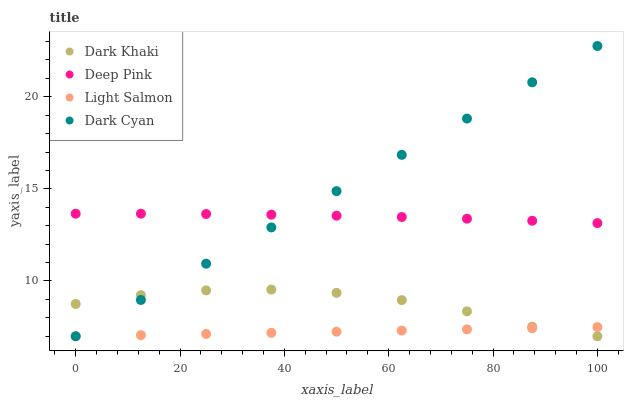Does Light Salmon have the minimum area under the curve?
Answer yes or no. Yes. Does Dark Cyan have the maximum area under the curve?
Answer yes or no. Yes. Does Dark Cyan have the minimum area under the curve?
Answer yes or no. No. Does Light Salmon have the maximum area under the curve?
Answer yes or no. No. Is Dark Cyan the smoothest?
Answer yes or no. Yes. Is Dark Khaki the roughest?
Answer yes or no. Yes. Is Light Salmon the smoothest?
Answer yes or no. No. Is Light Salmon the roughest?
Answer yes or no. No. Does Dark Khaki have the lowest value?
Answer yes or no. Yes. Does Deep Pink have the lowest value?
Answer yes or no. No. Does Dark Cyan have the highest value?
Answer yes or no. Yes. Does Light Salmon have the highest value?
Answer yes or no. No. Is Dark Khaki less than Deep Pink?
Answer yes or no. Yes. Is Deep Pink greater than Light Salmon?
Answer yes or no. Yes. Does Dark Cyan intersect Light Salmon?
Answer yes or no. Yes. Is Dark Cyan less than Light Salmon?
Answer yes or no. No. Is Dark Cyan greater than Light Salmon?
Answer yes or no. No. Does Dark Khaki intersect Deep Pink?
Answer yes or no. No. 